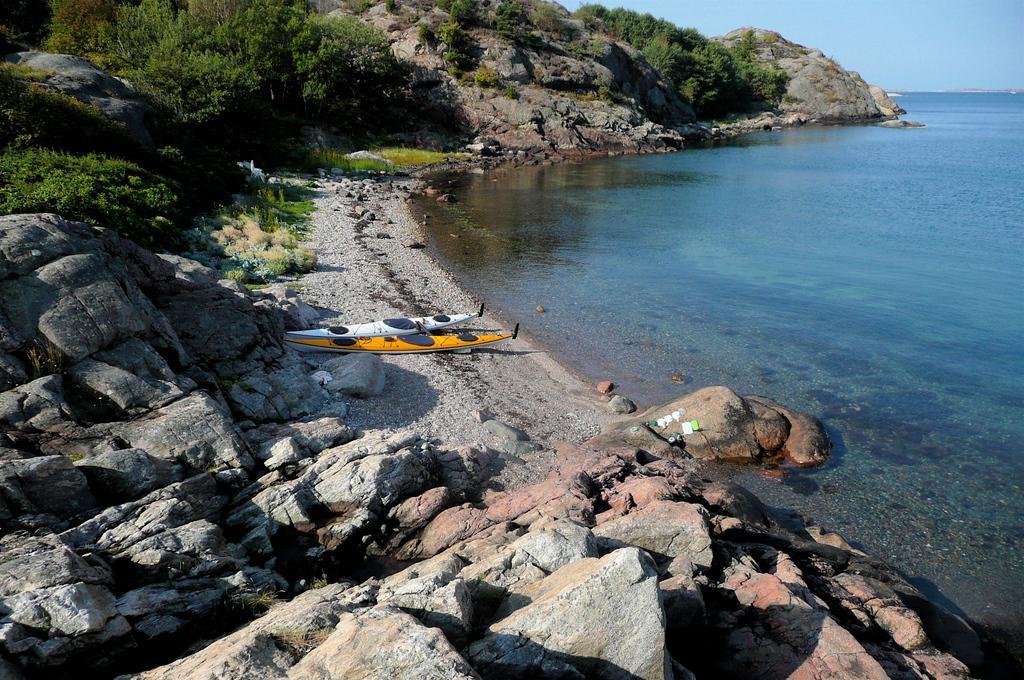In one or two sentences, can you explain what this image depicts? In this image we can see two boats on the surface. We can also see the rocks, trees and also the rock hill. On the right we can see the sea. Sky is also visible. 